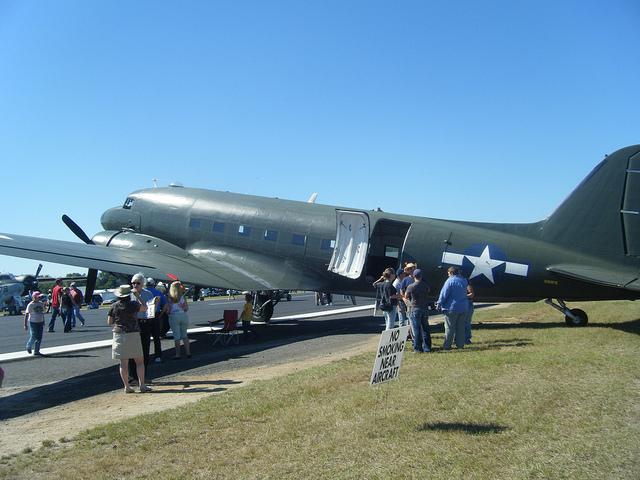What is the oldest military plane that is still in use?
Write a very short answer. This 1. How many shadows can you count?
Short answer required. 12. What is the people coming down from?
Answer briefly. Airplane. What shape is on the plane's tail?
Give a very brief answer. Star. What is prohibited by the sign in the grass?
Keep it brief. Smoking. 